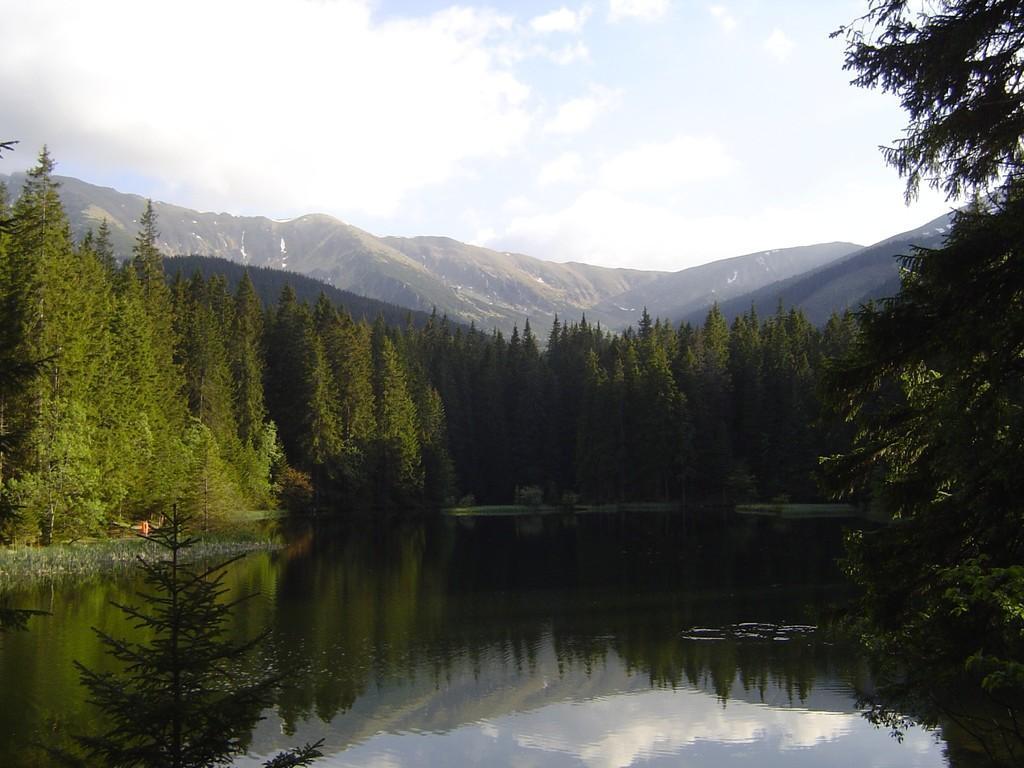Could you give a brief overview of what you see in this image? In this image we can see many trees and also some hills. At the top there is sky with the clouds and at the bottom there is lake. 